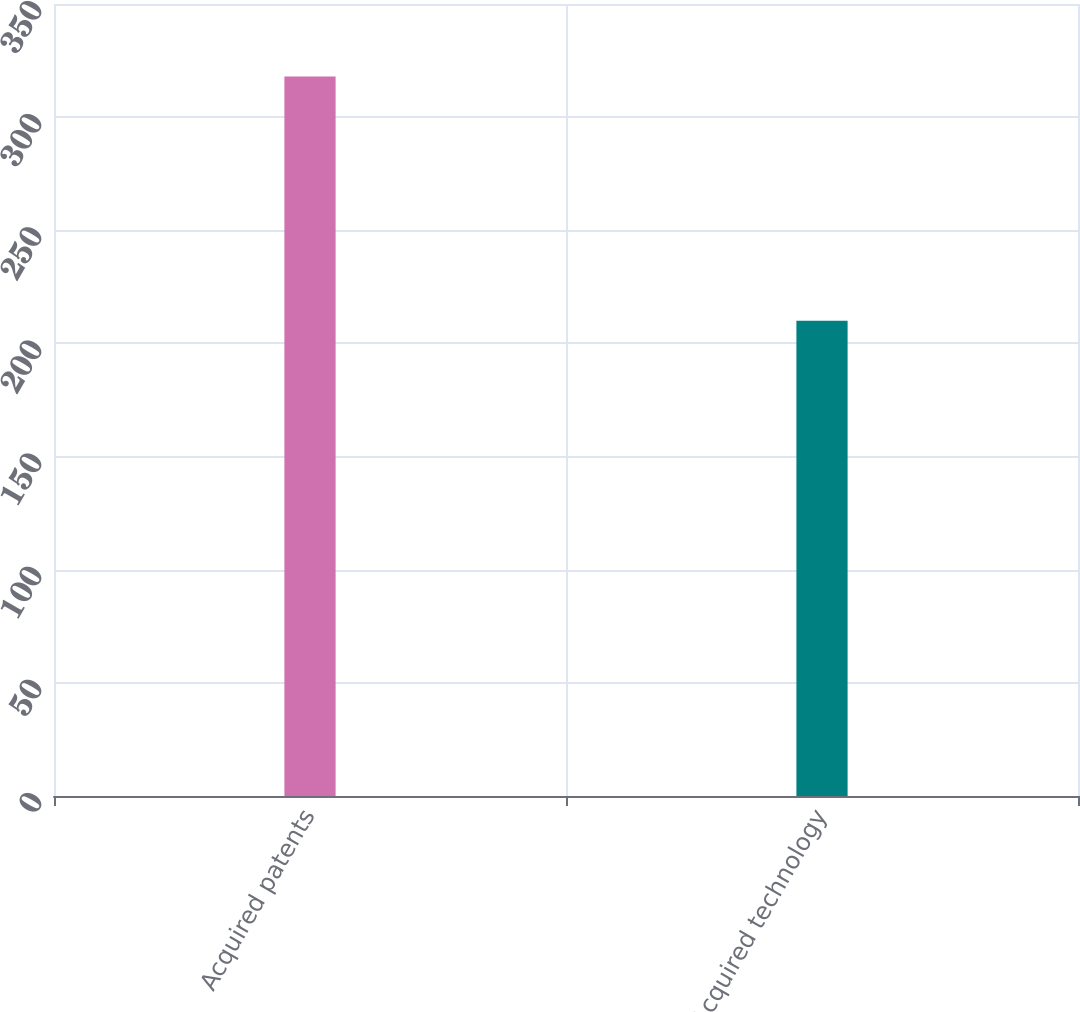Convert chart. <chart><loc_0><loc_0><loc_500><loc_500><bar_chart><fcel>Acquired patents<fcel>Acquired technology<nl><fcel>318<fcel>210<nl></chart> 